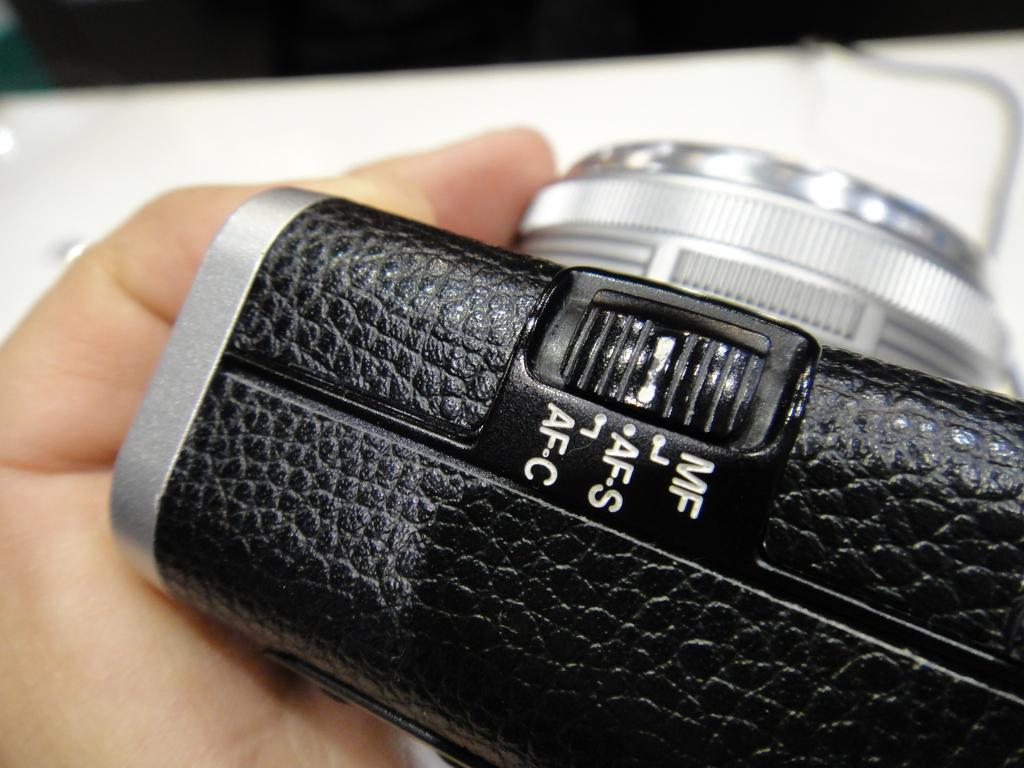What object is the main focus of the image? There is a camera in the image. Can you describe the position of the camera in the image? The camera is on a human hand. How many circles can be seen on the camera in the image? There are no circles visible on the camera in the image. What type of worm is crawling on the camera in the image? There are no worms present on the camera in the image. 